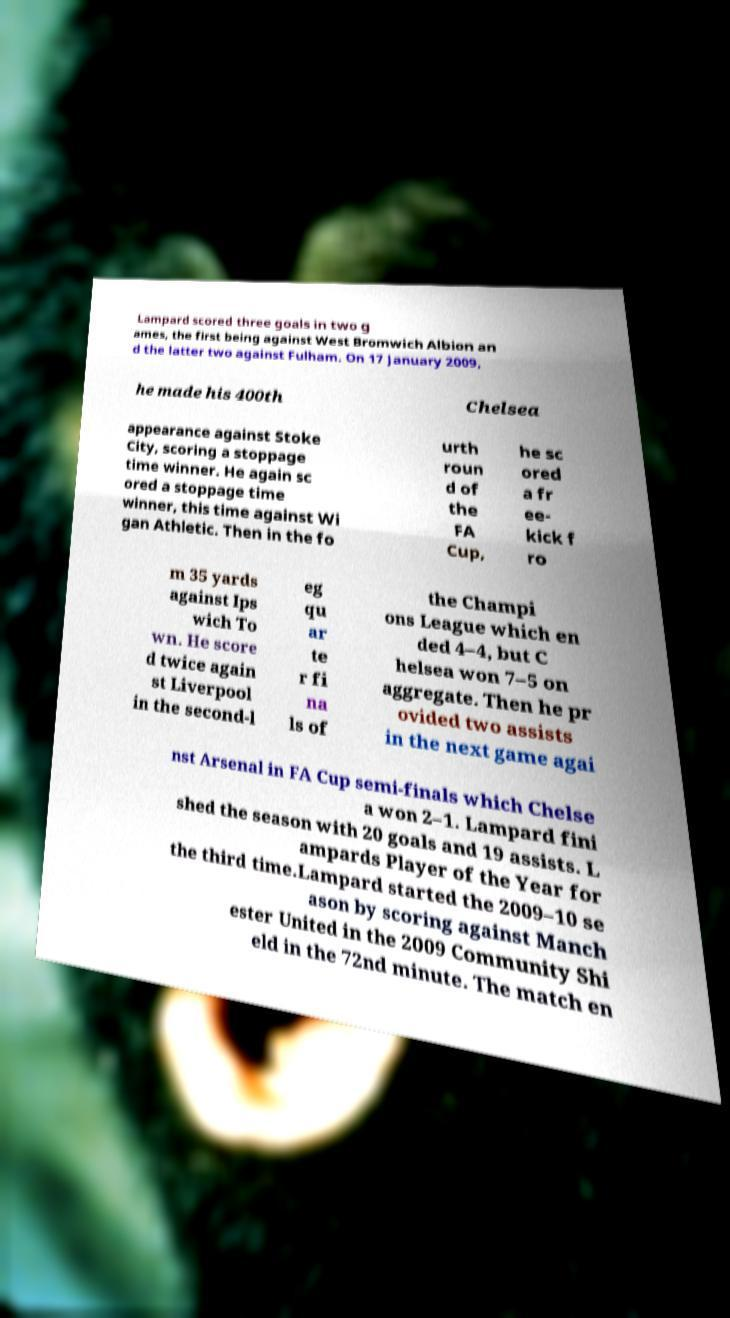Could you extract and type out the text from this image? Lampard scored three goals in two g ames, the first being against West Bromwich Albion an d the latter two against Fulham. On 17 January 2009, he made his 400th Chelsea appearance against Stoke City, scoring a stoppage time winner. He again sc ored a stoppage time winner, this time against Wi gan Athletic. Then in the fo urth roun d of the FA Cup, he sc ored a fr ee- kick f ro m 35 yards against Ips wich To wn. He score d twice again st Liverpool in the second-l eg qu ar te r fi na ls of the Champi ons League which en ded 4–4, but C helsea won 7–5 on aggregate. Then he pr ovided two assists in the next game agai nst Arsenal in FA Cup semi-finals which Chelse a won 2–1. Lampard fini shed the season with 20 goals and 19 assists. L ampards Player of the Year for the third time.Lampard started the 2009–10 se ason by scoring against Manch ester United in the 2009 Community Shi eld in the 72nd minute. The match en 